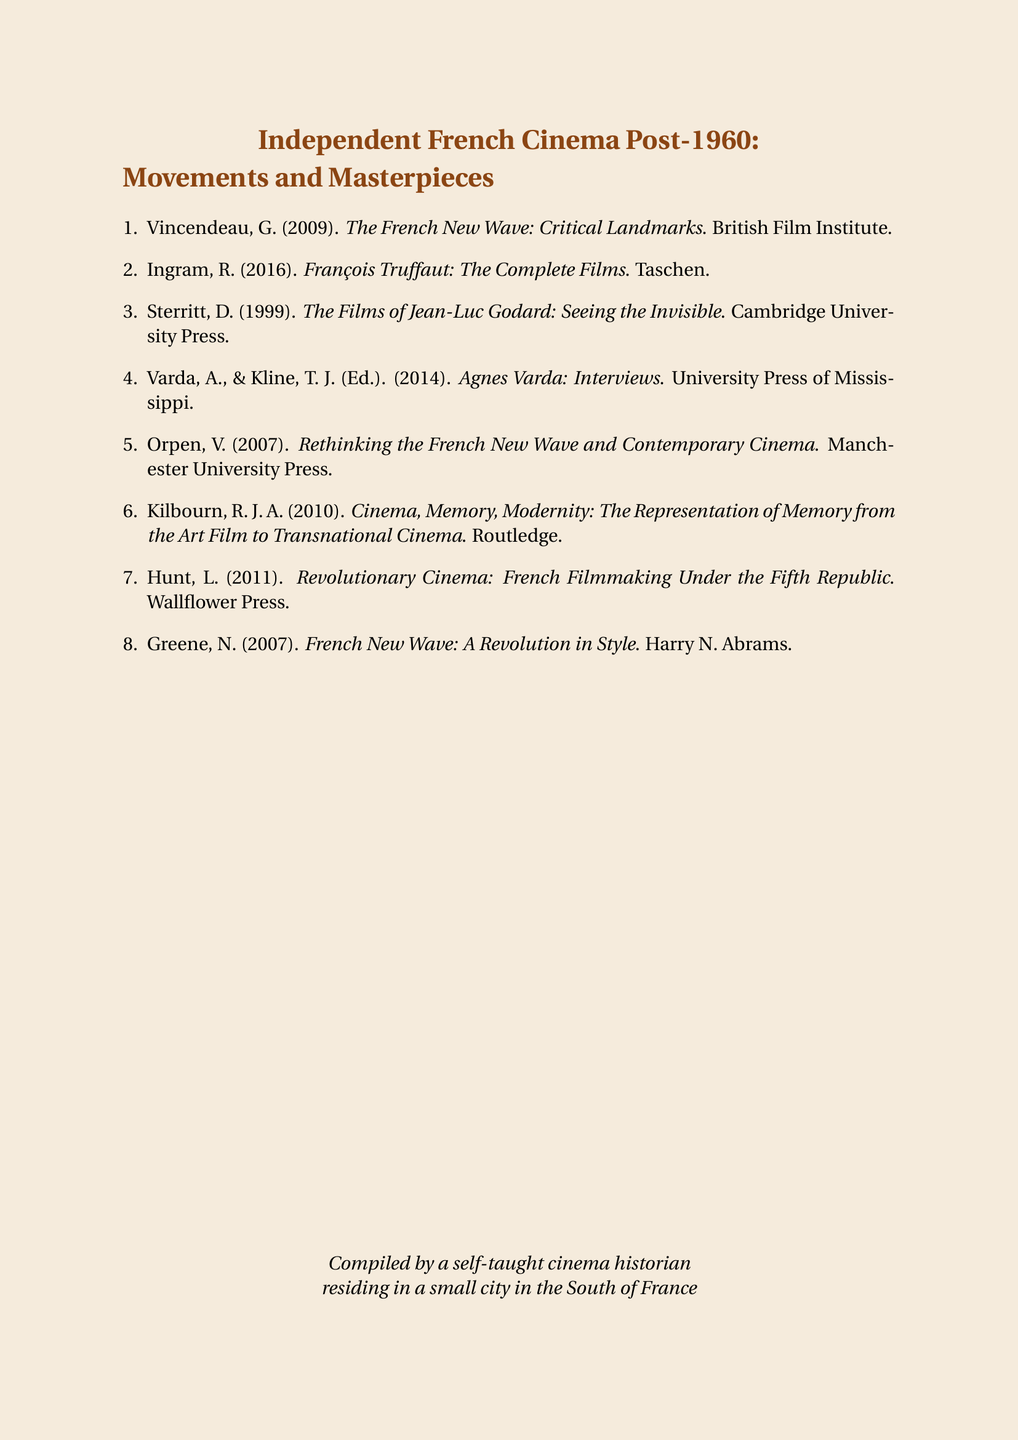What is the title of the collection? The title clearly states the focus on French cinema post-1960, including movements and masterpieces.
Answer: Independent French Cinema Post-1960: Movements and Masterpieces Who authored "The French New Wave: Critical Landmarks"? The document attributes this work to a specific author within the bibliography.
Answer: G. Vincendeau In what year was "François Truffaut: The Complete Films" published? The publication year is provided alongside the title in the bibliography.
Answer: 2016 Which university published "Agnes Varda: Interviews"? The document specifies the publishing institution for this work.
Answer: University Press of Mississippi How many works are listed in the bibliography? The total number of titles documented gives insight into the breadth of the subject covered.
Answer: 8 What subject does "Revolutionary Cinema" focus on? The title suggests a specific perspective on a particular era of French cinema.
Answer: French Filmmaking Under the Fifth Republic Who is one of the editors of "Agnes Varda: Interviews"? The document denotes editorial contributions, providing a clear connection to notable filmmakers.
Answer: T. J. Kline What publishing company released "French New Wave: A Revolution in Style"? The bibliography indicates the publisher responsible for this particular title's release.
Answer: Harry N. Abrams 